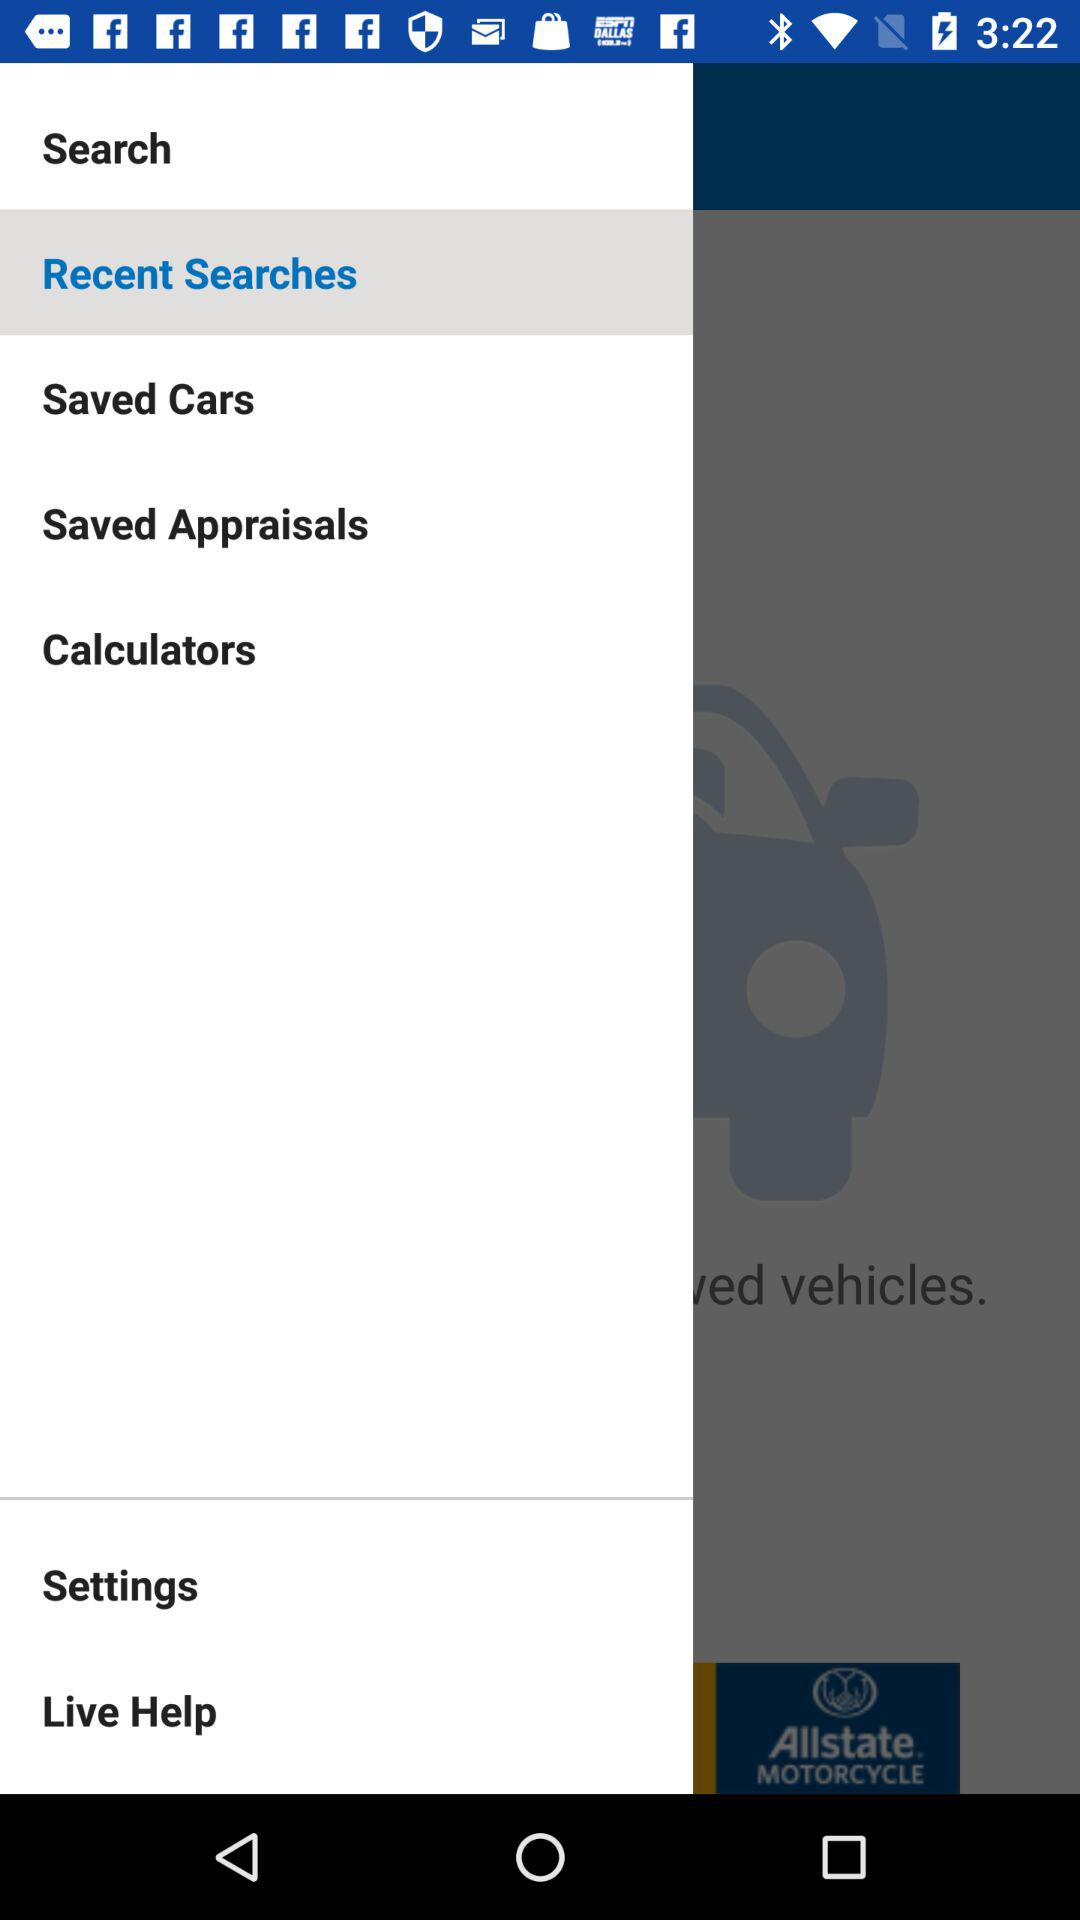What is the selected item? The selected item is "Recent Searches". 